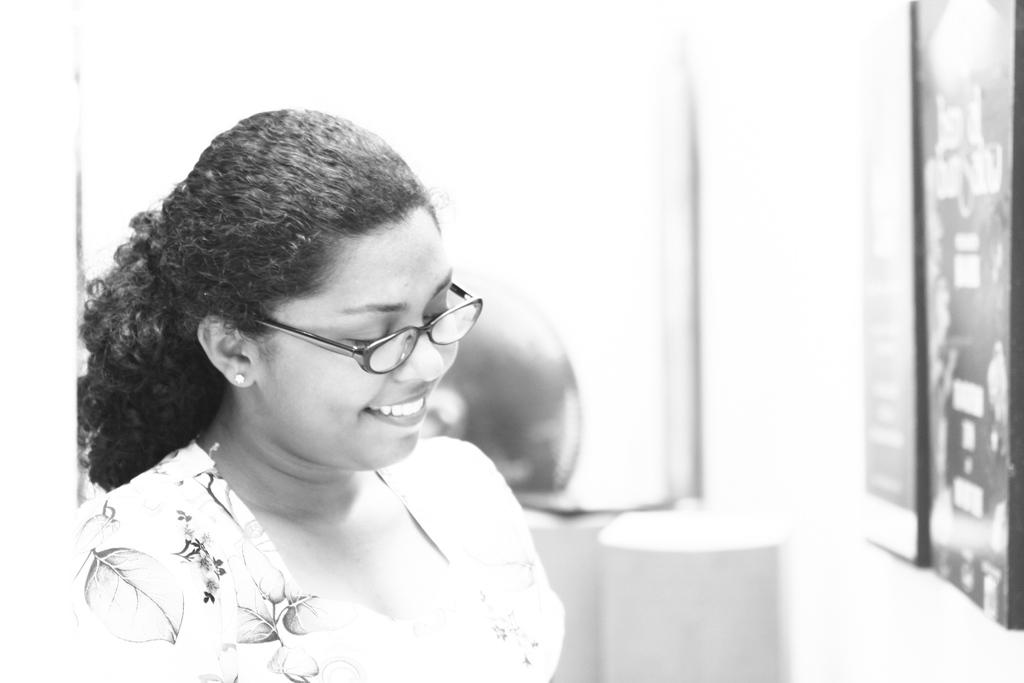What is the color scheme of the image? The image is black and white. Who or what is located in the center of the image? There are women in the center of the image. Where are the photo frames in the image? The photo frames are on the right side of the image, attached to the wall. What type of account does the grandfather have in the image? There is no mention of an account or a grandfather in the image. Can you see the sea in the background of the image? The image does not show any sea or water body in the background. 